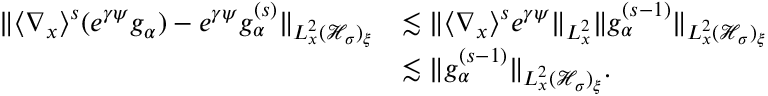Convert formula to latex. <formula><loc_0><loc_0><loc_500><loc_500>\begin{array} { r l } { \| \langle \nabla _ { x } \rangle ^ { s } ( e ^ { \gamma \psi } g _ { \alpha } ) - e ^ { \gamma \psi } g _ { \alpha } ^ { ( s ) } \| _ { L _ { x } ^ { 2 } ( \mathcal { H } _ { \sigma } ) _ { \xi } } } & { \lesssim \| \langle \nabla _ { x } \rangle ^ { s } e ^ { \gamma \psi } \| _ { L _ { x } ^ { 2 } } \| g _ { \alpha } ^ { ( s - 1 ) } \| _ { L _ { x } ^ { 2 } ( \mathcal { H } _ { \sigma } ) _ { \xi } } } \\ & { \lesssim \| g _ { \alpha } ^ { ( s - 1 ) } \| _ { L _ { x } ^ { 2 } ( \mathcal { H } _ { \sigma } ) _ { \xi } } . } \end{array}</formula> 